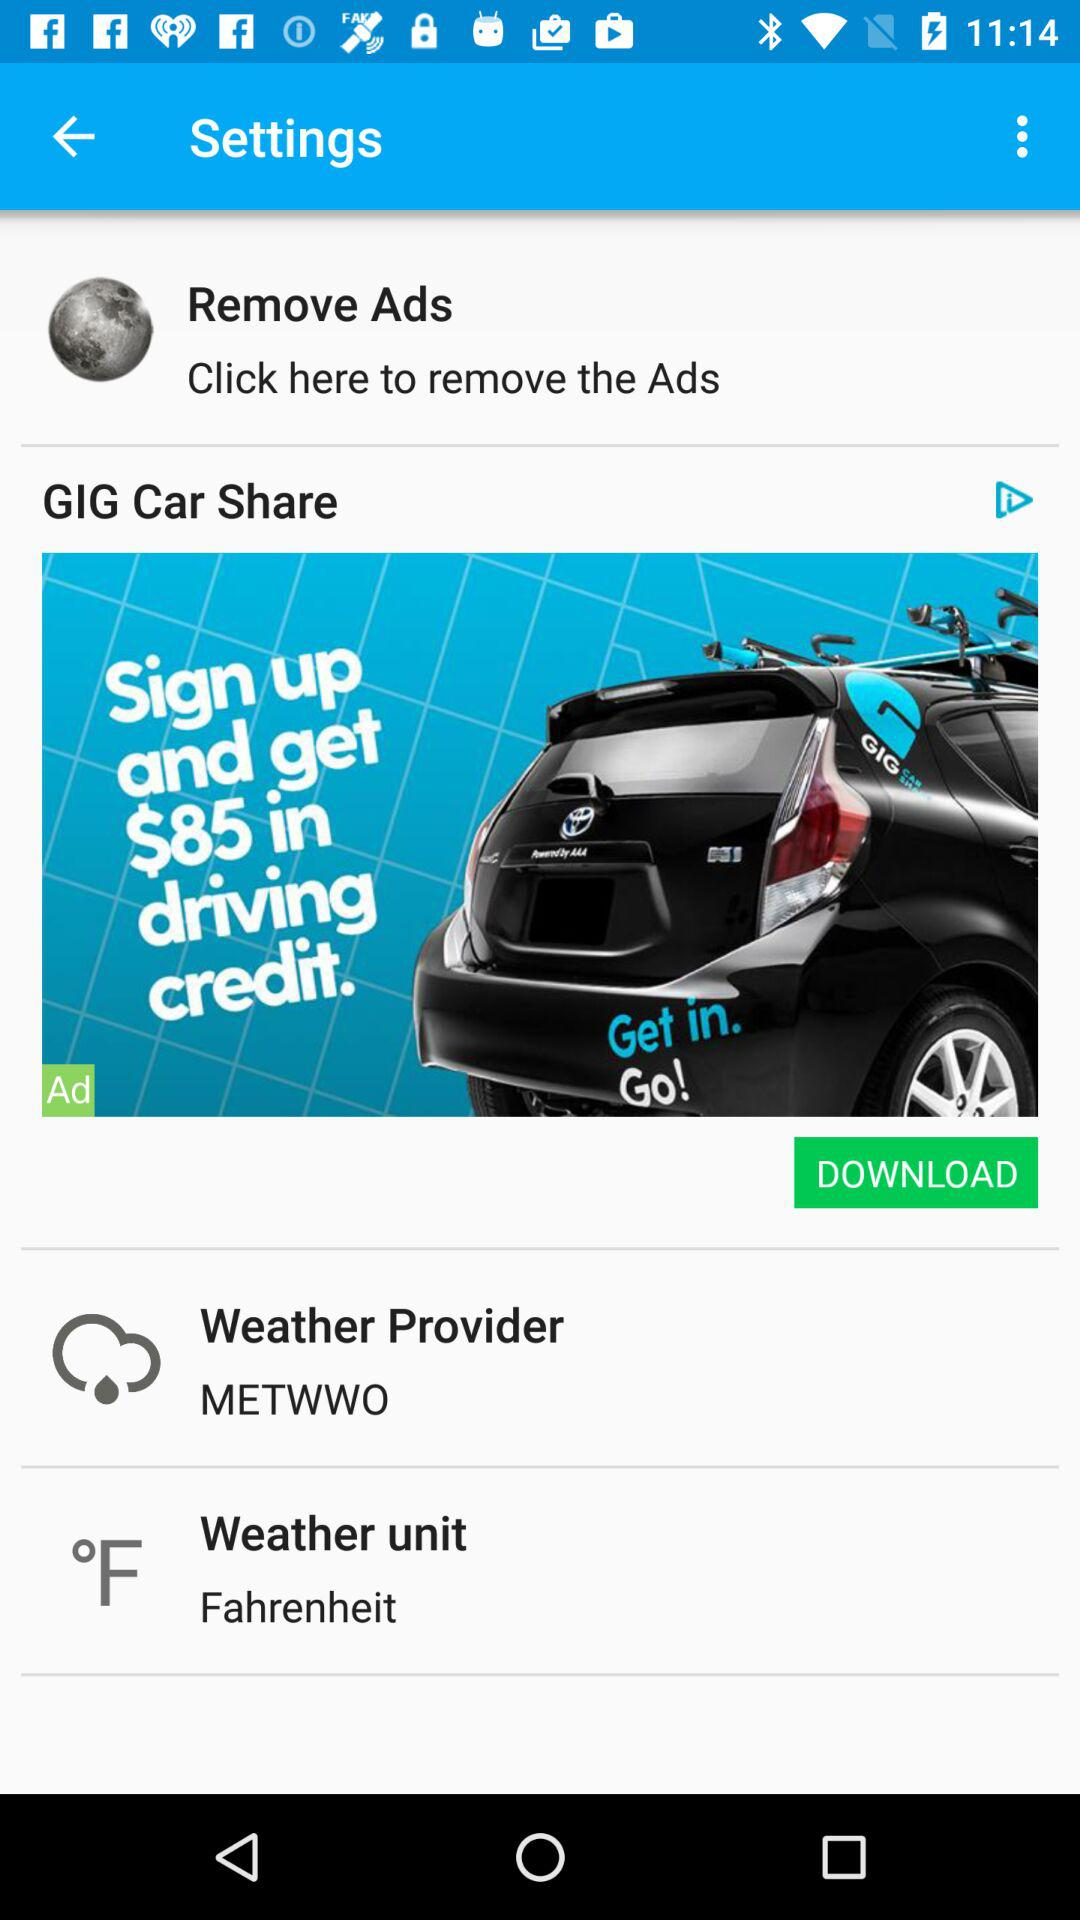What is the weather provider name? The weather provider name is "METWWO". 